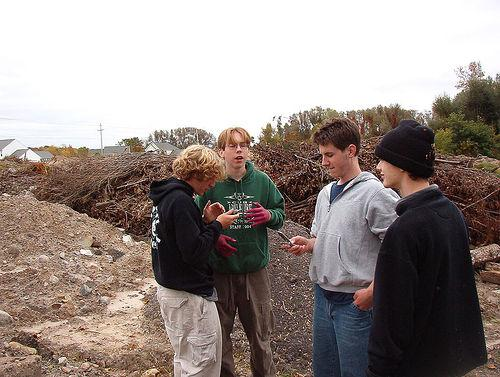Analyze the main emotion displayed by the boys in the image. The main emotion displayed by the boys in the image is a sense of camaraderie and togetherness. List three details about what the boy in the image is wearing. The boy is wearing a black coat, a black hat, and blue jeans. Provide a concise description of the central figure in this image. A boy wearing a coat, hat, pants, and holding a cell phone is the central figure in the image. Identify the color and type of clothing the kid in the image is wearing on his upper body. The kid is wearing a black coat and a gray hoody on his upper body. Count the number of distinct rocks visible in the image. There are five small distinct rocks on the ground visible in the image. Using complex reasoning, determine the main theme conveyed by the group of boys and their environment in the image. The main theme conveyed is youth, friendship, and casual outdoor activities, with a group of boys standing together in a dirt field, wearing casual clothing and engaging with each other. How many boys are standing together in the image and what are they doing? A group of four boys are standing together in a dirt field. Explain how the boy's wardrobe in the photo interacts with his activities. The boy's wardrobe, including coat, hat, pants, and phone, interacts with his casual outdoor activities and underlines his leading role in the group. Can you spot a dog in the picture? There is no mention of a dog or any animal in the image. Identify the activity the boy is doing involving the cell phone. holding a cell phone Investigate the ground in the image and describe what is found. several rocks on the ground Select the true statement from the image: a) A group of girls holding umbrellas b) Boys playing soccer c) Four boys standing together d) A boy playing video games. c) Four boys standing together Are any of the boys wearing shorts? There is no mention of shorts in the image. All the boys are wearing pants, jeans or another type of leg clothing. What object does the boy have in his hand? cell phone What color is the boy's sweater in the image? green What type of pants is the boy wearing in the image? blue jeans What type of gloves is the kid wearing in the photo? pink latex gloves What kind of shirt is the boy wearing in the picture? black sweater Describe the housing structures seen in the background of the image. the houses in the background Identify the boy's hair color in the picture. blonde What color is the coat the boy is wearing? black Is the boy wearing a red coat in the image? There is no mention of a red coat in the image, only a black coat. Enumerate the details about the hat the kid is wearing. black hat, boy Can you see a girl in the image? All captions mention 'boys' and 'kids,' implying that only boys are present, not girls. Use an alternative phrase to describe a boy in the image. this is a person Find the phrase that correctly describes the boy's hairstyle. short hair Does the kid wear yellow gloves? There is no mention of yellow gloves in the image, only pink latex gloves. Describe an activity in which the children in the image are involved. group of boys standing together Is there a tree in the background? There's no mention of a tree in the image; it only mentions houses in the background. Which of these items is the boy holding? a) cell phone b) car keys c) a pen d) a toy a) cell phone What kind of jacket is the other boy wearing in the image? gray jacket What type of clothing is worn by the boy holding a cell phone? a black sweatshirt List the clothing items the boy is wearing in the image. black coat, black hat, blue jeans Determine an activity done by the boy with his pocket. boy with his hand in his pocket 